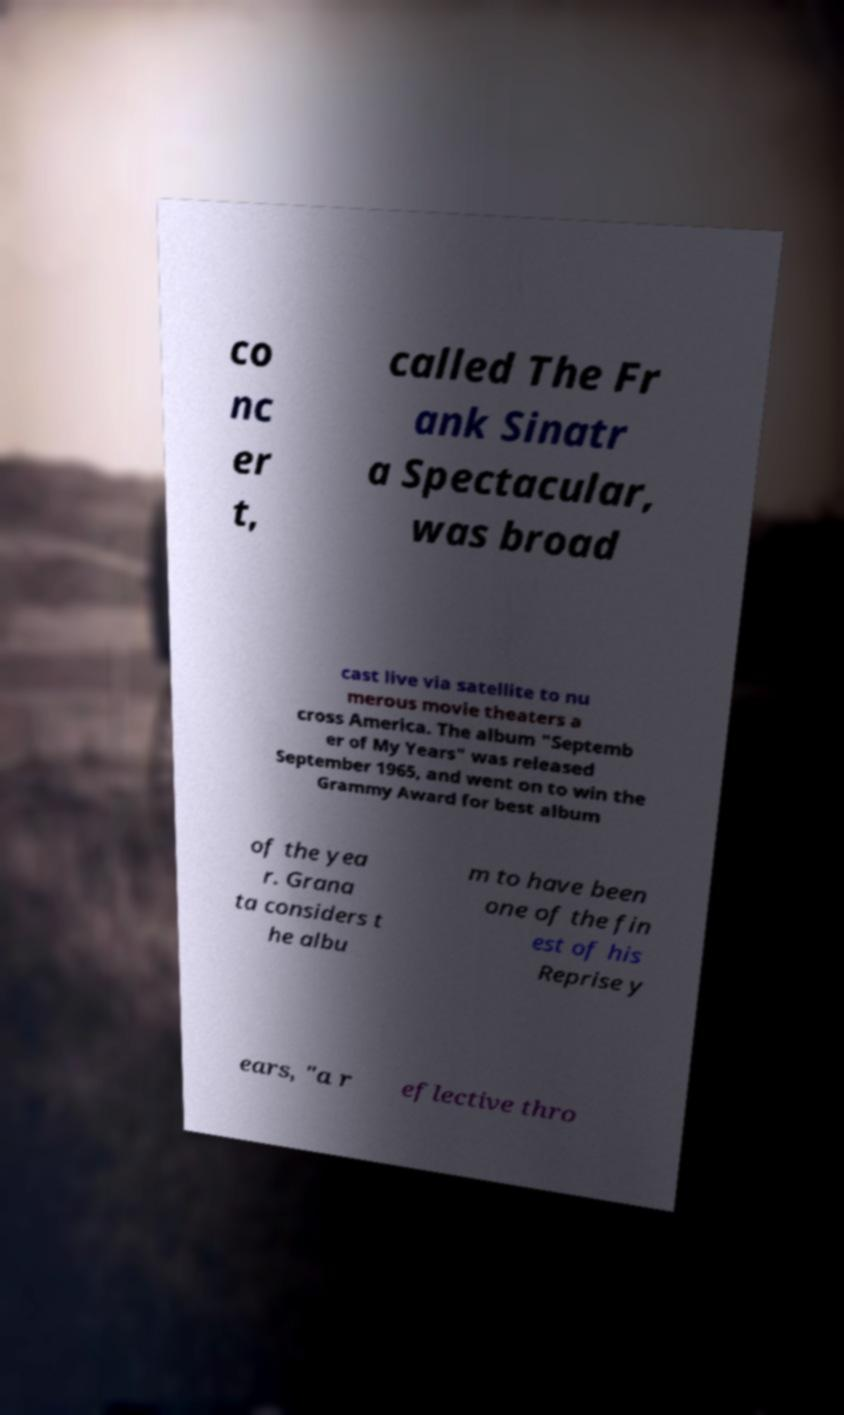For documentation purposes, I need the text within this image transcribed. Could you provide that? co nc er t, called The Fr ank Sinatr a Spectacular, was broad cast live via satellite to nu merous movie theaters a cross America. The album "Septemb er of My Years" was released September 1965, and went on to win the Grammy Award for best album of the yea r. Grana ta considers t he albu m to have been one of the fin est of his Reprise y ears, "a r eflective thro 